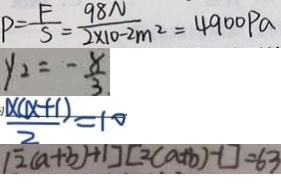<formula> <loc_0><loc_0><loc_500><loc_500>P = \frac { F } { S } = \frac { 9 8 N } { 2 \times 1 0 - 2 m ^ { 2 } } = 4 9 0 0 P a 
 y _ { 2 } = - \frac { 8 } { 3 } 
 \frac { x ( x + 1 ) } { 2 } = 1 0 
 [ 2 ( a + b ) + 1 ] [ 2 ( a + b ) - 1 ] = 6 3</formula> 